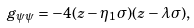Convert formula to latex. <formula><loc_0><loc_0><loc_500><loc_500>g _ { \psi \psi } = - 4 ( z - \eta _ { 1 } \sigma ) ( z - \lambda \sigma ) ,</formula> 